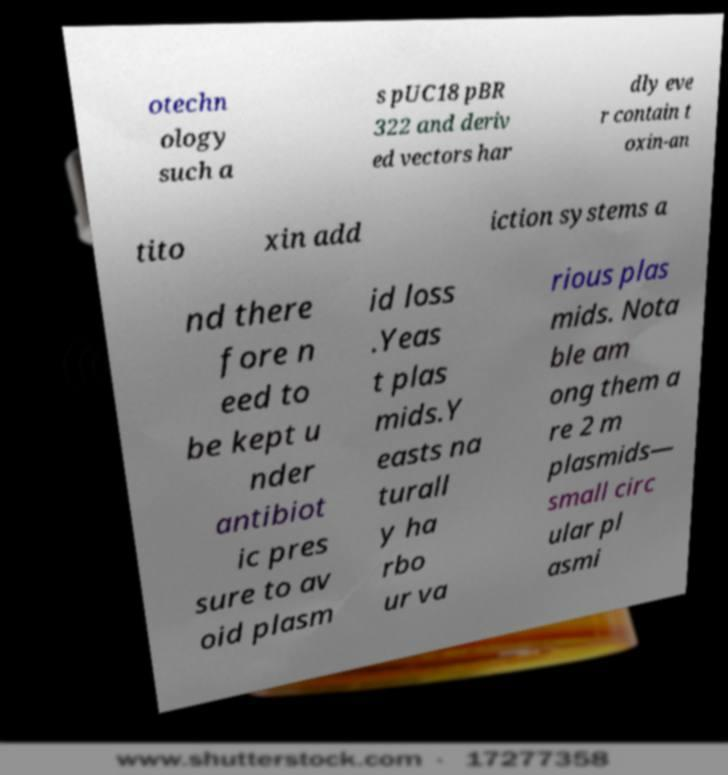Can you read and provide the text displayed in the image?This photo seems to have some interesting text. Can you extract and type it out for me? otechn ology such a s pUC18 pBR 322 and deriv ed vectors har dly eve r contain t oxin-an tito xin add iction systems a nd there fore n eed to be kept u nder antibiot ic pres sure to av oid plasm id loss .Yeas t plas mids.Y easts na turall y ha rbo ur va rious plas mids. Nota ble am ong them a re 2 m plasmids— small circ ular pl asmi 